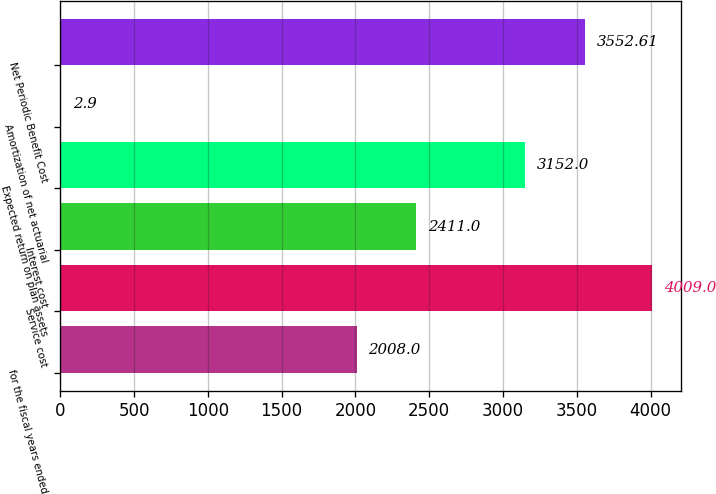<chart> <loc_0><loc_0><loc_500><loc_500><bar_chart><fcel>for the fiscal years ended<fcel>Service cost<fcel>Interest cost<fcel>Expected return on plan assets<fcel>Amortization of net actuarial<fcel>Net Periodic Benefit Cost<nl><fcel>2008<fcel>4009<fcel>2411<fcel>3152<fcel>2.9<fcel>3552.61<nl></chart> 